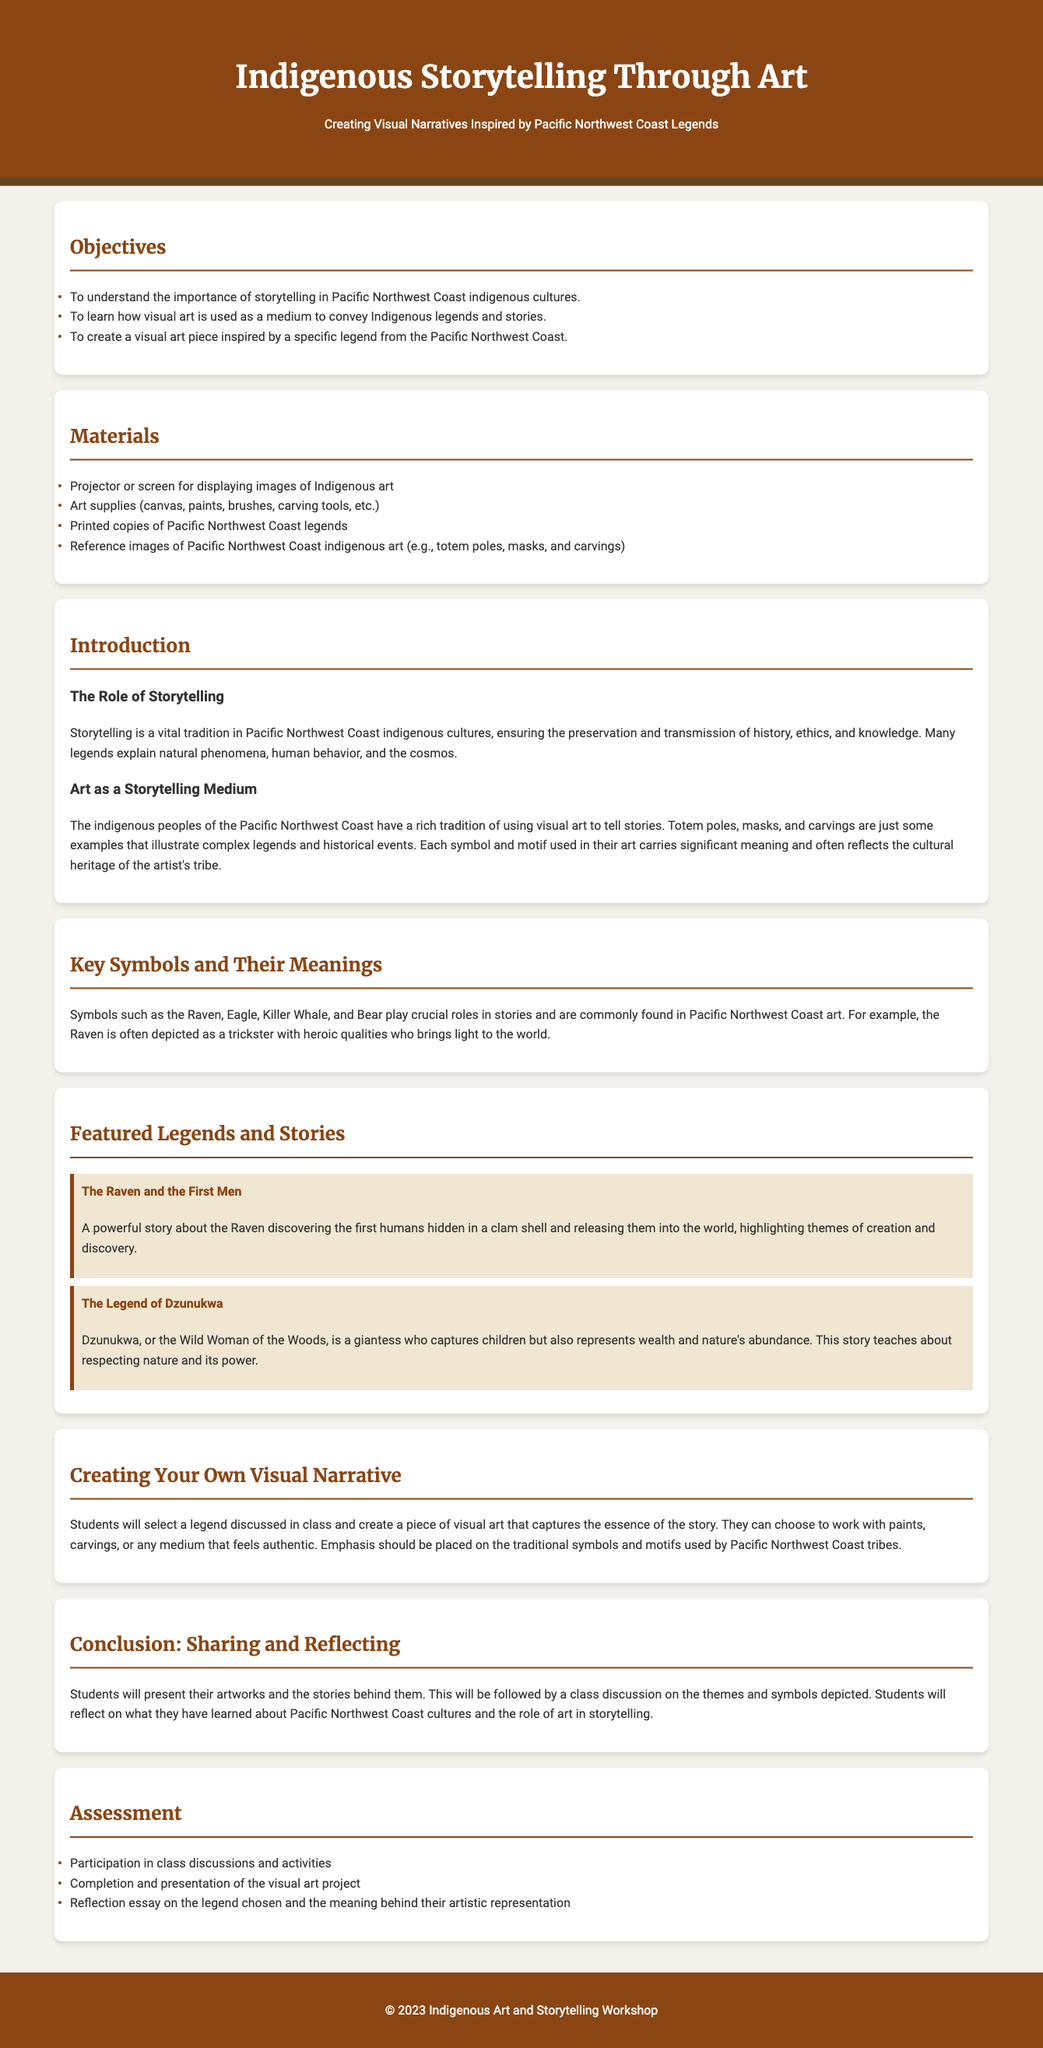What is the title of the lesson plan? The title of the lesson plan can be found in the header section of the document.
Answer: Indigenous Storytelling Through Art What is one of the objectives of the lesson plan? The objectives are listed under the "Objectives" section, highlighting the aims of the lesson.
Answer: To understand the importance of storytelling in Pacific Northwest Coast indigenous cultures What materials are needed for the lesson? The materials are listed under the "Materials" section, detailing what is required for the activities.
Answer: Art supplies (canvas, paints, brushes, carving tools, etc.) Who is the Wild Woman of the Woods in the featured legends? The featured legends describe key characters; one is specifically highlighted in the legend about Dzunukwa.
Answer: Dzunukwa What is the assessment criteria? The assessment criteria are mentioned in the "Assessment" section of the lesson plan, outlining how students will be evaluated.
Answer: Completion and presentation of the visual art project What role does the Raven play in Pacific Northwest Coast stories? The document mentions the Raven's significance within the context of storytelling and art as a symbol.
Answer: Trickster How will students present their artworks? This information is found in the "Conclusion" section, detailing the expectations for student presentations.
Answer: By presenting their artworks and the stories behind them What type of art will students create? The section on creating art specifies the kind of creative work students will undertake, in relation to their chosen legend.
Answer: A piece of visual art What theme does the legend of "The Raven and the First Men" highlight? Themes from legends are briefly discussed in the explanations given for featured stories.
Answer: Creation and discovery 